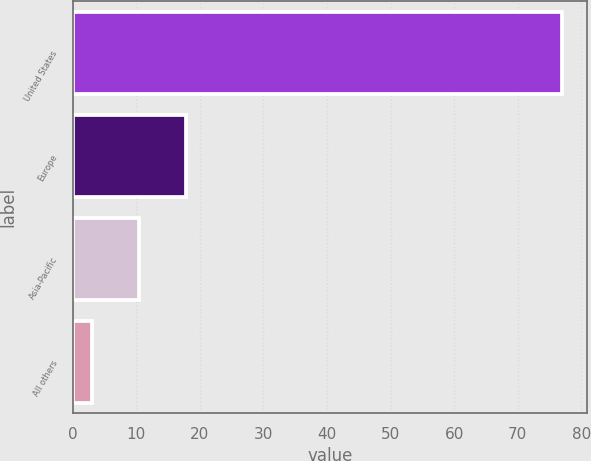Convert chart to OTSL. <chart><loc_0><loc_0><loc_500><loc_500><bar_chart><fcel>United States<fcel>Europe<fcel>Asia-Pacific<fcel>All others<nl><fcel>77<fcel>17.8<fcel>10.4<fcel>3<nl></chart> 